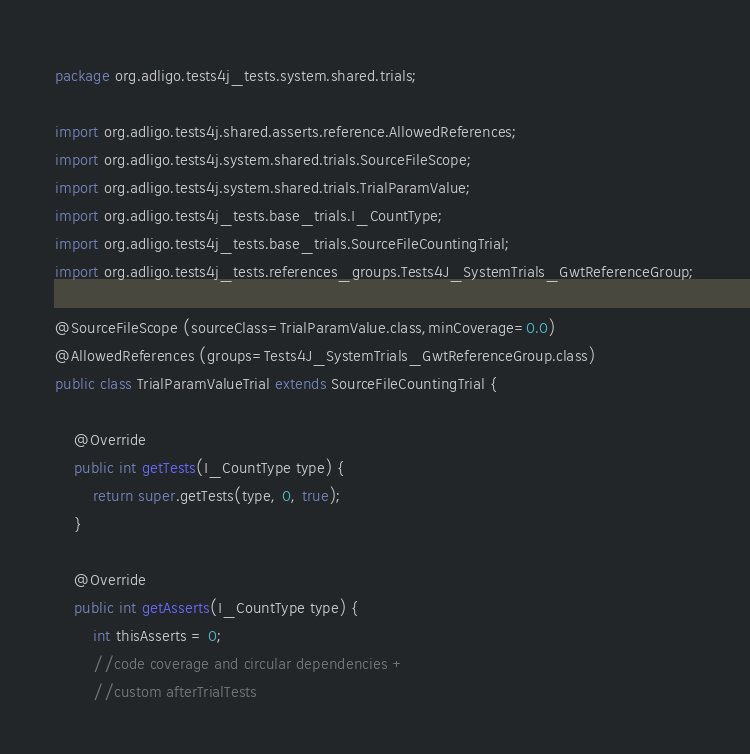Convert code to text. <code><loc_0><loc_0><loc_500><loc_500><_Java_>package org.adligo.tests4j_tests.system.shared.trials;

import org.adligo.tests4j.shared.asserts.reference.AllowedReferences;
import org.adligo.tests4j.system.shared.trials.SourceFileScope;
import org.adligo.tests4j.system.shared.trials.TrialParamValue;
import org.adligo.tests4j_tests.base_trials.I_CountType;
import org.adligo.tests4j_tests.base_trials.SourceFileCountingTrial;
import org.adligo.tests4j_tests.references_groups.Tests4J_SystemTrials_GwtReferenceGroup;

@SourceFileScope (sourceClass=TrialParamValue.class,minCoverage=0.0)
@AllowedReferences (groups=Tests4J_SystemTrials_GwtReferenceGroup.class)
public class TrialParamValueTrial extends SourceFileCountingTrial {

	@Override
	public int getTests(I_CountType type) {
		return super.getTests(type, 0, true);
	}

	@Override
	public int getAsserts(I_CountType type) {
		int thisAsserts = 0;
		//code coverage and circular dependencies +
		//custom afterTrialTests</code> 